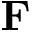Convert formula to latex. <formula><loc_0><loc_0><loc_500><loc_500>{ F }</formula> 